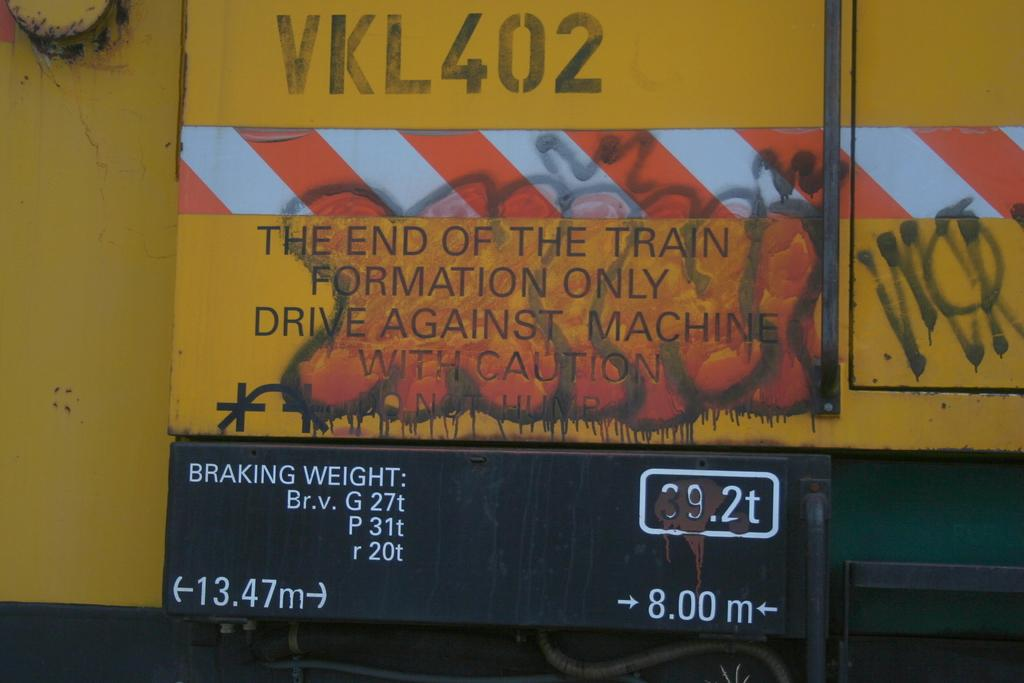<image>
Relay a brief, clear account of the picture shown. A sign with "The end of the train" among other things and graffiti on it. 